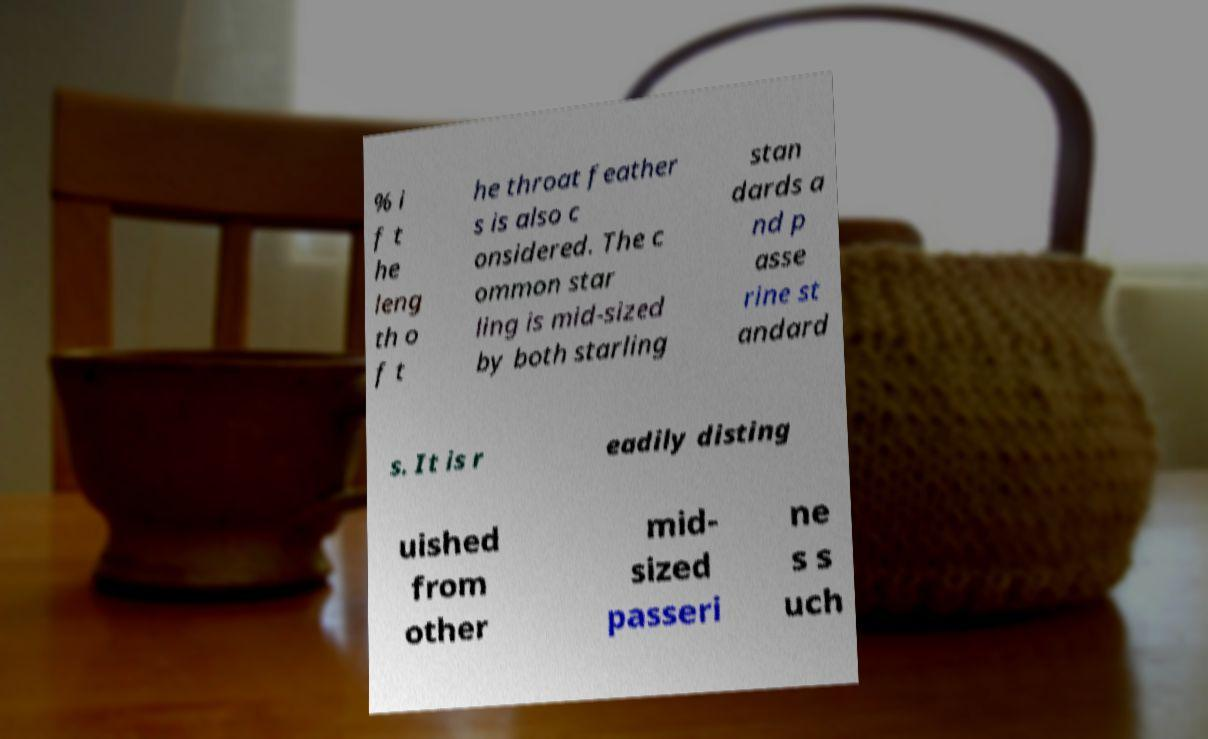Please read and relay the text visible in this image. What does it say? % i f t he leng th o f t he throat feather s is also c onsidered. The c ommon star ling is mid-sized by both starling stan dards a nd p asse rine st andard s. It is r eadily disting uished from other mid- sized passeri ne s s uch 